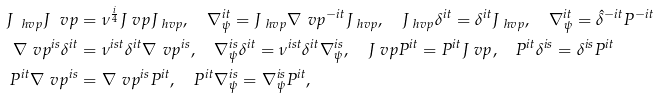Convert formula to latex. <formula><loc_0><loc_0><loc_500><loc_500>J _ { \ h v p } J _ { \ } v p & = \nu ^ { \frac { i } { 4 } } J _ { \ } v p J _ { \ h v p } , \quad \nabla _ { \psi } ^ { i t } = J _ { \ h v p } \nabla _ { \ } v p ^ { - i t } J _ { \ h v p } , \quad J _ { \ h v p } \delta ^ { i t } = \delta ^ { i t } J _ { \ h v p } , \quad \nabla _ { \psi } ^ { i t } = \hat { \delta } ^ { - i t } P ^ { - i t } \\ \nabla _ { \ } v p ^ { i s } \delta ^ { i t } & = \nu ^ { i s t } \delta ^ { i t } \nabla _ { \ } v p ^ { i s } , \quad \nabla _ { \psi } ^ { i s } \delta ^ { i t } = \nu ^ { i s t } \delta ^ { i t } \nabla _ { \psi } ^ { i s } , \quad J _ { \ } v p P ^ { i t } = P ^ { i t } J _ { \ } v p , \quad P ^ { i t } \delta ^ { i s } = \delta ^ { i s } P ^ { i t } \\ P ^ { i t } \nabla _ { \ } v p ^ { i s } & = \nabla _ { \ } v p ^ { i s } P ^ { i t } , \quad P ^ { i t } \nabla _ { \psi } ^ { i s } = \nabla _ { \psi } ^ { i s } P ^ { i t } ,</formula> 